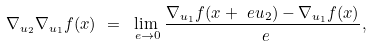<formula> <loc_0><loc_0><loc_500><loc_500>& \nabla _ { u _ { 2 } } \nabla _ { u _ { 1 } } f ( x ) \ = \ \lim _ { \ e \rightarrow 0 } \frac { \nabla _ { u _ { 1 } } f ( x + \ e u _ { 2 } ) - \nabla _ { u _ { 1 } } f ( x ) } { \ e } ,</formula> 